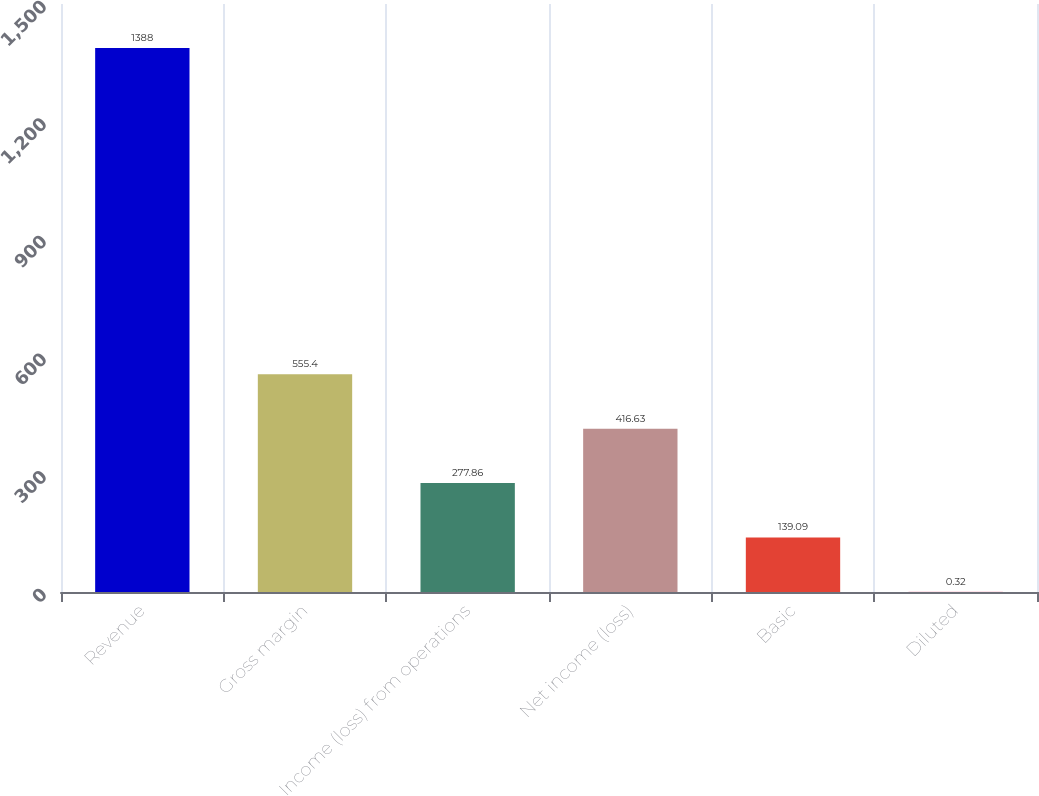Convert chart. <chart><loc_0><loc_0><loc_500><loc_500><bar_chart><fcel>Revenue<fcel>Gross margin<fcel>Income (loss) from operations<fcel>Net income (loss)<fcel>Basic<fcel>Diluted<nl><fcel>1388<fcel>555.4<fcel>277.86<fcel>416.63<fcel>139.09<fcel>0.32<nl></chart> 